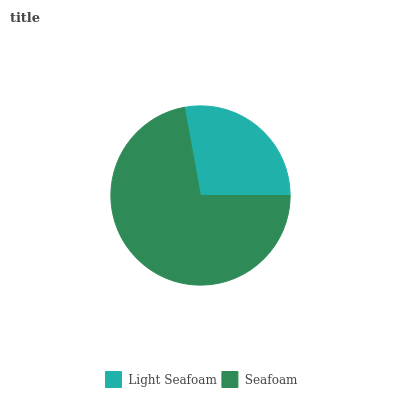Is Light Seafoam the minimum?
Answer yes or no. Yes. Is Seafoam the maximum?
Answer yes or no. Yes. Is Seafoam the minimum?
Answer yes or no. No. Is Seafoam greater than Light Seafoam?
Answer yes or no. Yes. Is Light Seafoam less than Seafoam?
Answer yes or no. Yes. Is Light Seafoam greater than Seafoam?
Answer yes or no. No. Is Seafoam less than Light Seafoam?
Answer yes or no. No. Is Seafoam the high median?
Answer yes or no. Yes. Is Light Seafoam the low median?
Answer yes or no. Yes. Is Light Seafoam the high median?
Answer yes or no. No. Is Seafoam the low median?
Answer yes or no. No. 